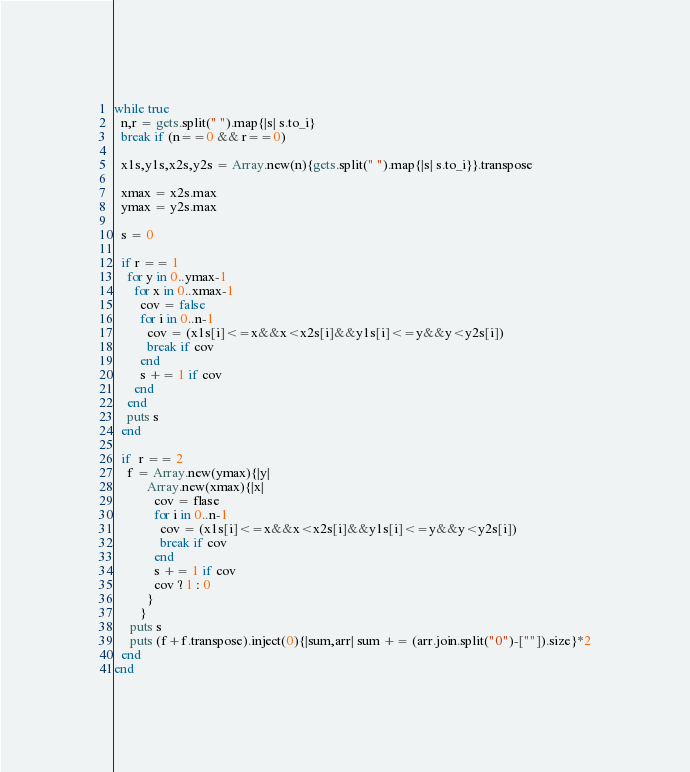<code> <loc_0><loc_0><loc_500><loc_500><_Ruby_>while true
  n,r = gets.split(" ").map{|s| s.to_i}
  break if (n==0 && r==0)
  
  x1s,y1s,x2s,y2s = Array.new(n){gets.split(" ").map{|s| s.to_i}}.transpose
  
  xmax = x2s.max
  ymax = y2s.max

  s = 0

  if r == 1
    for y in 0..ymax-1
      for x in 0..xmax-1
        cov = false
        for i in 0..n-1
          cov = (x1s[i]<=x&&x<x2s[i]&&y1s[i]<=y&&y<y2s[i])
          break if cov
        end
        s += 1 if cov
      end
    end
    puts s
  end

  if  r == 2
    f = Array.new(ymax){|y|
          Array.new(xmax){|x|
            cov = flase
            for i in 0..n-1
              cov = (x1s[i]<=x&&x<x2s[i]&&y1s[i]<=y&&y<y2s[i])
              break if cov
            end
            s += 1 if cov
            cov ? 1 : 0
          }
        }
     puts s
     puts (f+f.transpose).inject(0){|sum,arr| sum += (arr.join.split("0")-[""]).size}*2
  end
end</code> 